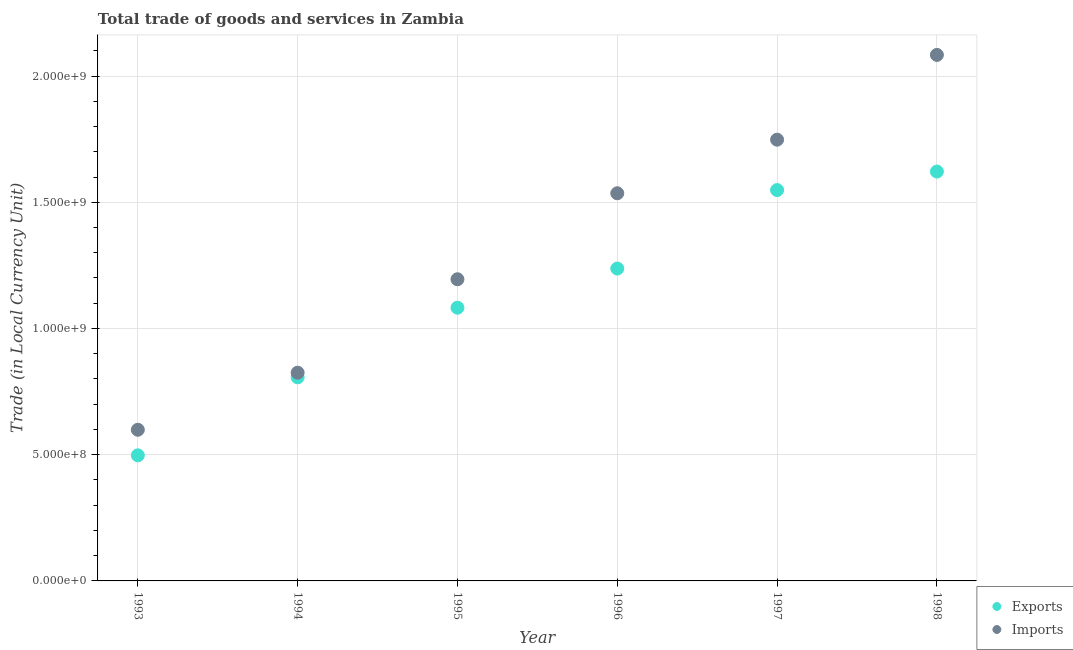How many different coloured dotlines are there?
Your answer should be very brief. 2. What is the export of goods and services in 1993?
Give a very brief answer. 4.98e+08. Across all years, what is the maximum imports of goods and services?
Keep it short and to the point. 2.08e+09. Across all years, what is the minimum imports of goods and services?
Offer a very short reply. 5.99e+08. What is the total imports of goods and services in the graph?
Offer a terse response. 7.99e+09. What is the difference between the export of goods and services in 1993 and that in 1998?
Your response must be concise. -1.12e+09. What is the difference between the export of goods and services in 1998 and the imports of goods and services in 1995?
Make the answer very short. 4.27e+08. What is the average export of goods and services per year?
Make the answer very short. 1.13e+09. In the year 1994, what is the difference between the imports of goods and services and export of goods and services?
Your response must be concise. 1.84e+07. In how many years, is the export of goods and services greater than 1200000000 LCU?
Your answer should be compact. 3. What is the ratio of the imports of goods and services in 1997 to that in 1998?
Offer a very short reply. 0.84. Is the export of goods and services in 1993 less than that in 1997?
Give a very brief answer. Yes. What is the difference between the highest and the second highest imports of goods and services?
Give a very brief answer. 3.36e+08. What is the difference between the highest and the lowest imports of goods and services?
Make the answer very short. 1.49e+09. Is the imports of goods and services strictly greater than the export of goods and services over the years?
Your answer should be very brief. Yes. Are the values on the major ticks of Y-axis written in scientific E-notation?
Your response must be concise. Yes. Does the graph contain grids?
Offer a very short reply. Yes. Where does the legend appear in the graph?
Provide a succinct answer. Bottom right. How are the legend labels stacked?
Provide a short and direct response. Vertical. What is the title of the graph?
Provide a short and direct response. Total trade of goods and services in Zambia. What is the label or title of the Y-axis?
Provide a succinct answer. Trade (in Local Currency Unit). What is the Trade (in Local Currency Unit) in Exports in 1993?
Keep it short and to the point. 4.98e+08. What is the Trade (in Local Currency Unit) of Imports in 1993?
Give a very brief answer. 5.99e+08. What is the Trade (in Local Currency Unit) in Exports in 1994?
Provide a short and direct response. 8.07e+08. What is the Trade (in Local Currency Unit) in Imports in 1994?
Keep it short and to the point. 8.25e+08. What is the Trade (in Local Currency Unit) of Exports in 1995?
Your answer should be compact. 1.08e+09. What is the Trade (in Local Currency Unit) of Imports in 1995?
Offer a very short reply. 1.20e+09. What is the Trade (in Local Currency Unit) of Exports in 1996?
Provide a short and direct response. 1.24e+09. What is the Trade (in Local Currency Unit) of Imports in 1996?
Ensure brevity in your answer.  1.54e+09. What is the Trade (in Local Currency Unit) of Exports in 1997?
Your answer should be compact. 1.55e+09. What is the Trade (in Local Currency Unit) of Imports in 1997?
Your response must be concise. 1.75e+09. What is the Trade (in Local Currency Unit) in Exports in 1998?
Offer a very short reply. 1.62e+09. What is the Trade (in Local Currency Unit) of Imports in 1998?
Your response must be concise. 2.08e+09. Across all years, what is the maximum Trade (in Local Currency Unit) in Exports?
Your answer should be very brief. 1.62e+09. Across all years, what is the maximum Trade (in Local Currency Unit) in Imports?
Keep it short and to the point. 2.08e+09. Across all years, what is the minimum Trade (in Local Currency Unit) in Exports?
Give a very brief answer. 4.98e+08. Across all years, what is the minimum Trade (in Local Currency Unit) in Imports?
Make the answer very short. 5.99e+08. What is the total Trade (in Local Currency Unit) in Exports in the graph?
Make the answer very short. 6.79e+09. What is the total Trade (in Local Currency Unit) of Imports in the graph?
Offer a very short reply. 7.99e+09. What is the difference between the Trade (in Local Currency Unit) in Exports in 1993 and that in 1994?
Your answer should be compact. -3.09e+08. What is the difference between the Trade (in Local Currency Unit) of Imports in 1993 and that in 1994?
Offer a terse response. -2.26e+08. What is the difference between the Trade (in Local Currency Unit) in Exports in 1993 and that in 1995?
Keep it short and to the point. -5.85e+08. What is the difference between the Trade (in Local Currency Unit) of Imports in 1993 and that in 1995?
Offer a very short reply. -5.96e+08. What is the difference between the Trade (in Local Currency Unit) in Exports in 1993 and that in 1996?
Give a very brief answer. -7.40e+08. What is the difference between the Trade (in Local Currency Unit) of Imports in 1993 and that in 1996?
Offer a very short reply. -9.37e+08. What is the difference between the Trade (in Local Currency Unit) of Exports in 1993 and that in 1997?
Your answer should be compact. -1.05e+09. What is the difference between the Trade (in Local Currency Unit) in Imports in 1993 and that in 1997?
Give a very brief answer. -1.15e+09. What is the difference between the Trade (in Local Currency Unit) in Exports in 1993 and that in 1998?
Ensure brevity in your answer.  -1.12e+09. What is the difference between the Trade (in Local Currency Unit) in Imports in 1993 and that in 1998?
Provide a short and direct response. -1.49e+09. What is the difference between the Trade (in Local Currency Unit) in Exports in 1994 and that in 1995?
Offer a terse response. -2.76e+08. What is the difference between the Trade (in Local Currency Unit) in Imports in 1994 and that in 1995?
Offer a very short reply. -3.70e+08. What is the difference between the Trade (in Local Currency Unit) in Exports in 1994 and that in 1996?
Make the answer very short. -4.31e+08. What is the difference between the Trade (in Local Currency Unit) in Imports in 1994 and that in 1996?
Ensure brevity in your answer.  -7.11e+08. What is the difference between the Trade (in Local Currency Unit) in Exports in 1994 and that in 1997?
Give a very brief answer. -7.42e+08. What is the difference between the Trade (in Local Currency Unit) in Imports in 1994 and that in 1997?
Offer a very short reply. -9.23e+08. What is the difference between the Trade (in Local Currency Unit) in Exports in 1994 and that in 1998?
Offer a terse response. -8.15e+08. What is the difference between the Trade (in Local Currency Unit) of Imports in 1994 and that in 1998?
Provide a succinct answer. -1.26e+09. What is the difference between the Trade (in Local Currency Unit) of Exports in 1995 and that in 1996?
Keep it short and to the point. -1.55e+08. What is the difference between the Trade (in Local Currency Unit) in Imports in 1995 and that in 1996?
Make the answer very short. -3.41e+08. What is the difference between the Trade (in Local Currency Unit) in Exports in 1995 and that in 1997?
Your answer should be compact. -4.66e+08. What is the difference between the Trade (in Local Currency Unit) in Imports in 1995 and that in 1997?
Your answer should be compact. -5.53e+08. What is the difference between the Trade (in Local Currency Unit) in Exports in 1995 and that in 1998?
Provide a short and direct response. -5.39e+08. What is the difference between the Trade (in Local Currency Unit) in Imports in 1995 and that in 1998?
Give a very brief answer. -8.89e+08. What is the difference between the Trade (in Local Currency Unit) of Exports in 1996 and that in 1997?
Provide a short and direct response. -3.11e+08. What is the difference between the Trade (in Local Currency Unit) in Imports in 1996 and that in 1997?
Offer a very short reply. -2.12e+08. What is the difference between the Trade (in Local Currency Unit) in Exports in 1996 and that in 1998?
Your response must be concise. -3.84e+08. What is the difference between the Trade (in Local Currency Unit) of Imports in 1996 and that in 1998?
Offer a very short reply. -5.48e+08. What is the difference between the Trade (in Local Currency Unit) in Exports in 1997 and that in 1998?
Make the answer very short. -7.34e+07. What is the difference between the Trade (in Local Currency Unit) in Imports in 1997 and that in 1998?
Provide a short and direct response. -3.36e+08. What is the difference between the Trade (in Local Currency Unit) in Exports in 1993 and the Trade (in Local Currency Unit) in Imports in 1994?
Your response must be concise. -3.27e+08. What is the difference between the Trade (in Local Currency Unit) of Exports in 1993 and the Trade (in Local Currency Unit) of Imports in 1995?
Keep it short and to the point. -6.97e+08. What is the difference between the Trade (in Local Currency Unit) in Exports in 1993 and the Trade (in Local Currency Unit) in Imports in 1996?
Provide a succinct answer. -1.04e+09. What is the difference between the Trade (in Local Currency Unit) of Exports in 1993 and the Trade (in Local Currency Unit) of Imports in 1997?
Provide a short and direct response. -1.25e+09. What is the difference between the Trade (in Local Currency Unit) in Exports in 1993 and the Trade (in Local Currency Unit) in Imports in 1998?
Provide a short and direct response. -1.59e+09. What is the difference between the Trade (in Local Currency Unit) in Exports in 1994 and the Trade (in Local Currency Unit) in Imports in 1995?
Keep it short and to the point. -3.88e+08. What is the difference between the Trade (in Local Currency Unit) in Exports in 1994 and the Trade (in Local Currency Unit) in Imports in 1996?
Provide a short and direct response. -7.29e+08. What is the difference between the Trade (in Local Currency Unit) in Exports in 1994 and the Trade (in Local Currency Unit) in Imports in 1997?
Ensure brevity in your answer.  -9.41e+08. What is the difference between the Trade (in Local Currency Unit) in Exports in 1994 and the Trade (in Local Currency Unit) in Imports in 1998?
Offer a very short reply. -1.28e+09. What is the difference between the Trade (in Local Currency Unit) of Exports in 1995 and the Trade (in Local Currency Unit) of Imports in 1996?
Offer a terse response. -4.53e+08. What is the difference between the Trade (in Local Currency Unit) in Exports in 1995 and the Trade (in Local Currency Unit) in Imports in 1997?
Your response must be concise. -6.66e+08. What is the difference between the Trade (in Local Currency Unit) of Exports in 1995 and the Trade (in Local Currency Unit) of Imports in 1998?
Keep it short and to the point. -1.00e+09. What is the difference between the Trade (in Local Currency Unit) in Exports in 1996 and the Trade (in Local Currency Unit) in Imports in 1997?
Your answer should be compact. -5.11e+08. What is the difference between the Trade (in Local Currency Unit) of Exports in 1996 and the Trade (in Local Currency Unit) of Imports in 1998?
Keep it short and to the point. -8.46e+08. What is the difference between the Trade (in Local Currency Unit) of Exports in 1997 and the Trade (in Local Currency Unit) of Imports in 1998?
Your answer should be compact. -5.35e+08. What is the average Trade (in Local Currency Unit) of Exports per year?
Make the answer very short. 1.13e+09. What is the average Trade (in Local Currency Unit) in Imports per year?
Provide a short and direct response. 1.33e+09. In the year 1993, what is the difference between the Trade (in Local Currency Unit) in Exports and Trade (in Local Currency Unit) in Imports?
Provide a short and direct response. -1.01e+08. In the year 1994, what is the difference between the Trade (in Local Currency Unit) in Exports and Trade (in Local Currency Unit) in Imports?
Offer a terse response. -1.84e+07. In the year 1995, what is the difference between the Trade (in Local Currency Unit) in Exports and Trade (in Local Currency Unit) in Imports?
Give a very brief answer. -1.13e+08. In the year 1996, what is the difference between the Trade (in Local Currency Unit) of Exports and Trade (in Local Currency Unit) of Imports?
Provide a short and direct response. -2.98e+08. In the year 1997, what is the difference between the Trade (in Local Currency Unit) of Exports and Trade (in Local Currency Unit) of Imports?
Offer a terse response. -2.00e+08. In the year 1998, what is the difference between the Trade (in Local Currency Unit) in Exports and Trade (in Local Currency Unit) in Imports?
Keep it short and to the point. -4.62e+08. What is the ratio of the Trade (in Local Currency Unit) in Exports in 1993 to that in 1994?
Your answer should be very brief. 0.62. What is the ratio of the Trade (in Local Currency Unit) in Imports in 1993 to that in 1994?
Offer a very short reply. 0.73. What is the ratio of the Trade (in Local Currency Unit) in Exports in 1993 to that in 1995?
Give a very brief answer. 0.46. What is the ratio of the Trade (in Local Currency Unit) of Imports in 1993 to that in 1995?
Offer a terse response. 0.5. What is the ratio of the Trade (in Local Currency Unit) of Exports in 1993 to that in 1996?
Ensure brevity in your answer.  0.4. What is the ratio of the Trade (in Local Currency Unit) in Imports in 1993 to that in 1996?
Your response must be concise. 0.39. What is the ratio of the Trade (in Local Currency Unit) of Exports in 1993 to that in 1997?
Give a very brief answer. 0.32. What is the ratio of the Trade (in Local Currency Unit) of Imports in 1993 to that in 1997?
Provide a short and direct response. 0.34. What is the ratio of the Trade (in Local Currency Unit) in Exports in 1993 to that in 1998?
Your answer should be compact. 0.31. What is the ratio of the Trade (in Local Currency Unit) of Imports in 1993 to that in 1998?
Provide a succinct answer. 0.29. What is the ratio of the Trade (in Local Currency Unit) of Exports in 1994 to that in 1995?
Make the answer very short. 0.75. What is the ratio of the Trade (in Local Currency Unit) in Imports in 1994 to that in 1995?
Your answer should be very brief. 0.69. What is the ratio of the Trade (in Local Currency Unit) of Exports in 1994 to that in 1996?
Provide a succinct answer. 0.65. What is the ratio of the Trade (in Local Currency Unit) of Imports in 1994 to that in 1996?
Keep it short and to the point. 0.54. What is the ratio of the Trade (in Local Currency Unit) in Exports in 1994 to that in 1997?
Make the answer very short. 0.52. What is the ratio of the Trade (in Local Currency Unit) in Imports in 1994 to that in 1997?
Offer a terse response. 0.47. What is the ratio of the Trade (in Local Currency Unit) of Exports in 1994 to that in 1998?
Offer a very short reply. 0.5. What is the ratio of the Trade (in Local Currency Unit) of Imports in 1994 to that in 1998?
Your answer should be very brief. 0.4. What is the ratio of the Trade (in Local Currency Unit) in Exports in 1995 to that in 1996?
Ensure brevity in your answer.  0.87. What is the ratio of the Trade (in Local Currency Unit) in Imports in 1995 to that in 1996?
Provide a short and direct response. 0.78. What is the ratio of the Trade (in Local Currency Unit) in Exports in 1995 to that in 1997?
Provide a short and direct response. 0.7. What is the ratio of the Trade (in Local Currency Unit) of Imports in 1995 to that in 1997?
Provide a succinct answer. 0.68. What is the ratio of the Trade (in Local Currency Unit) of Exports in 1995 to that in 1998?
Keep it short and to the point. 0.67. What is the ratio of the Trade (in Local Currency Unit) in Imports in 1995 to that in 1998?
Make the answer very short. 0.57. What is the ratio of the Trade (in Local Currency Unit) of Exports in 1996 to that in 1997?
Your answer should be very brief. 0.8. What is the ratio of the Trade (in Local Currency Unit) in Imports in 1996 to that in 1997?
Keep it short and to the point. 0.88. What is the ratio of the Trade (in Local Currency Unit) in Exports in 1996 to that in 1998?
Your answer should be compact. 0.76. What is the ratio of the Trade (in Local Currency Unit) of Imports in 1996 to that in 1998?
Make the answer very short. 0.74. What is the ratio of the Trade (in Local Currency Unit) of Exports in 1997 to that in 1998?
Your answer should be compact. 0.95. What is the ratio of the Trade (in Local Currency Unit) of Imports in 1997 to that in 1998?
Make the answer very short. 0.84. What is the difference between the highest and the second highest Trade (in Local Currency Unit) in Exports?
Your answer should be very brief. 7.34e+07. What is the difference between the highest and the second highest Trade (in Local Currency Unit) of Imports?
Offer a very short reply. 3.36e+08. What is the difference between the highest and the lowest Trade (in Local Currency Unit) in Exports?
Keep it short and to the point. 1.12e+09. What is the difference between the highest and the lowest Trade (in Local Currency Unit) of Imports?
Ensure brevity in your answer.  1.49e+09. 